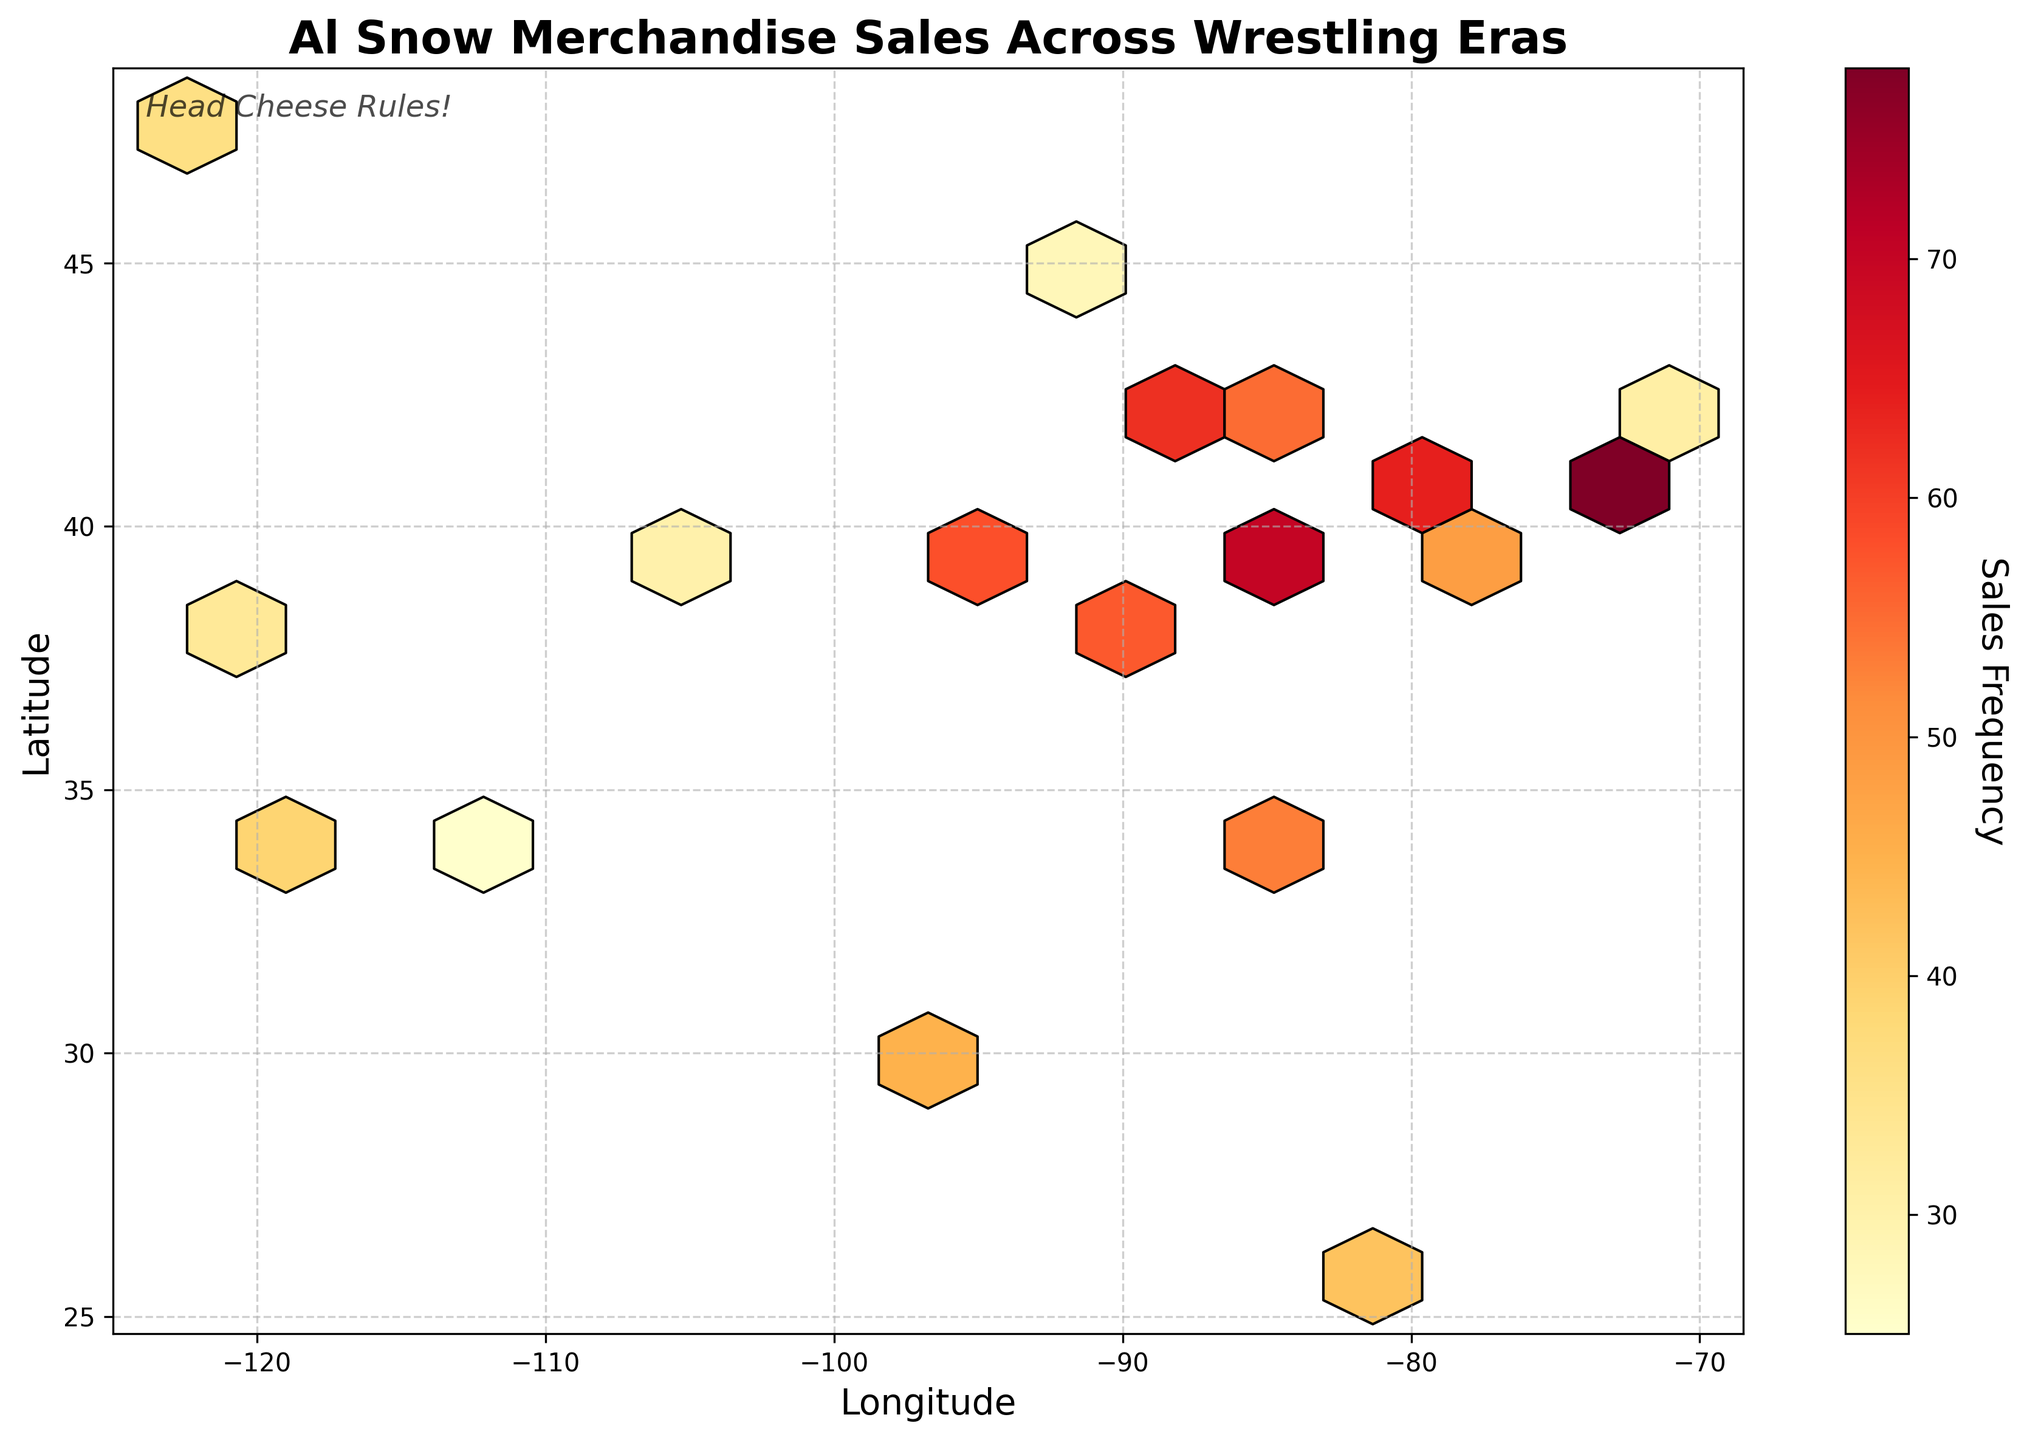what is the title of the figure? The title is typically found at the top of the figure, visually distinctive with larger and bold font. The title describes the overall subject of the plot.
Answer: Al Snow Merchandise Sales Across Wrestling Eras What do the colors in the hexagons represent? The color of the hexagons indicates the sales frequency, as shown by the color bar on the side. Darker colors represent higher frequencies.
Answer: Sales Frequency Which location had the highest sales frequency? By examining the color intensity in the hexagons, we can identify the location with the darkest color (deepest shade).
Answer: New York (Longitude -73.9352, Latitude 40.7306) What range of sales frequencies does the color bar indicate? The color bar next to the hexbin plot transitions from light to dark, signaling the range of sales frequency values. Observing the numeric values on the bar clarifies this range.
Answer: 25 to 78 Is there any annotation or text within the plot area? Checking the plot area reveals any added text or notes intended to provide additional information or context to the plot.
Answer: Yes, "Head Cheese Rules!" Which city has the second-highest sales frequency? By comparing the intensity of the hexagon colors, we can find the hexagon with the second darkest color, not to be confused with the darkest.
Answer: Chicago (Longitude -87.6298, Latitude 41.8781) How many sales frequencies are greater than 50? By examining the color bar and the corresponding hexagons, count the hexagons that exhibit colors in the range above 50 in the color bar.
Answer: Six What is the average sales frequency of the listed data points? To calculate the mean sales frequency, add all the frequency values and divide by the total number of data points. The data points are visible in the plot with their respective frequencies.
Answer: 47 Compare the sales frequencies in Detroit and Miami. Which has higher sales frequency? Look at the hexagon colors associated with the coordinates of Detroit and Miami. Identify the higher frequency based on the darker shade.
Answer: Detroit Explain how geographic location affects sales frequency patterns. To explain geographic patterns, observe clusters of dark hexagons indicating higher sales and light hexagons for lower sales. Note any prominent regions, especially large cities or specific states, and consider potential reasons for these patterns, like population size or wrestling fanbase concentrations.
Answer: Higher frequencies often cluster around major cities like New York and Chicago, influenced by larger populations and possibly a stronger wrestling fanbase 